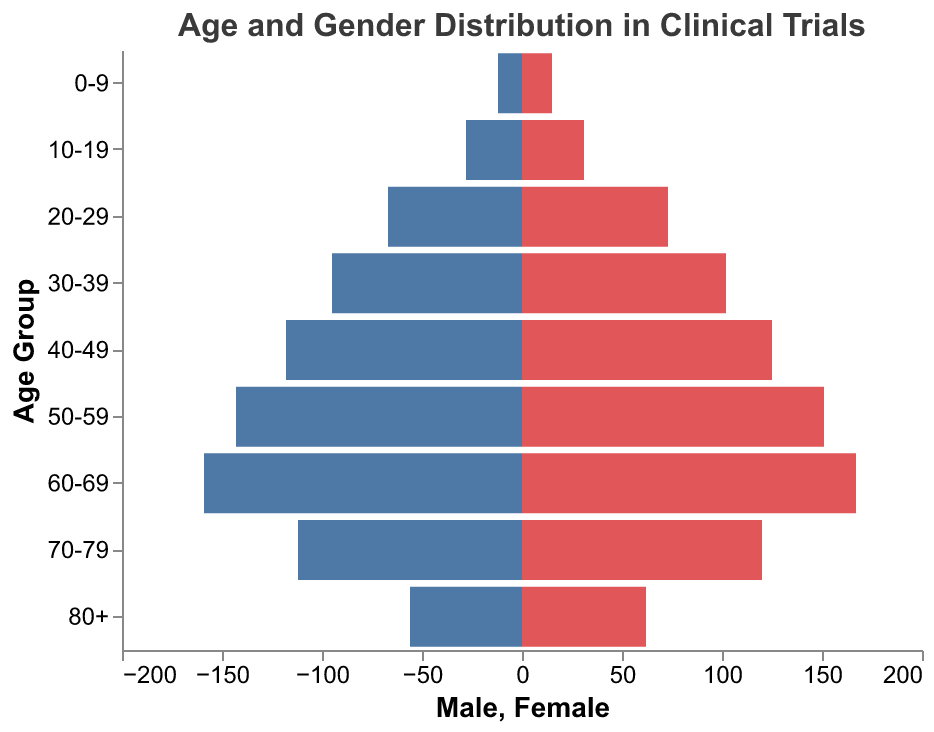What's the title of the figure? The title of the figure is usually found at the top. It provides a summary of what the figure depicts. Looking at the figure, the title states "Age and Gender Distribution in Clinical Trials".
Answer: Age and Gender Distribution in Clinical Trials How many age groups are represented in the figure? The age groups are listed along the y-axis. Counting all the individual entries, there are 9 distinct age groups shown.
Answer: 9 Which age group has the highest number of male participants? To find the age group with the highest number of male participants, we compare the lengths of the blue bars representing each age group. The age group 60-69 has the longest blue bar, indicating it has the most male participants at 159.
Answer: 60-69 What is the total number of participants in the 50-59 age group? To find the total number of participants in the 50-59 age group, add the number of males (143) and females (151) together. This results in 143 + 151 = 294.
Answer: 294 Which gender has more participants in the 70-79 age group? Compare the lengths of the blue and red bars for the age group 70-79. The red bar is slightly longer than the blue bar, indicating there are more female participants (120) than male participants (112).
Answer: Female Compare the number of male and female participants in the 30-39 age group. Which is higher and by how much? Examine the lengths of the bars for the 30-39 age group. The female bar (102) is slightly taller than the male bar (95). To find the difference, subtract the number of males from the number of females: 102 - 95 = 7.
Answer: Female by 7 What is the difference in the number of participants between the 40-49 and 80+ age groups? First, find the total participants for each group. For the 40-49 group, it's 118 (male) + 125 (female) = 243. For the 80+ group, it's 56 (male) + 62 (female) = 118. The difference is 243 - 118 = 125.
Answer: 125 Which age group has the smallest gender gap, and what is that gap? Examine the differences between male and female bars for each age group. For the 10-19 group, males are 28 and females are 31, resulting in a gender gap of 3. No other age group has a smaller gap.
Answer: 10-19, 3 How do the overall trends in male and female participation compare as the age increases? From the figure, look at how the lengths of the bars (both male and female) change across age groups. Both genders increase in numbers up to 60-69 and then decline after that age group.
Answer: Both increase up to 60-69, then decrease 